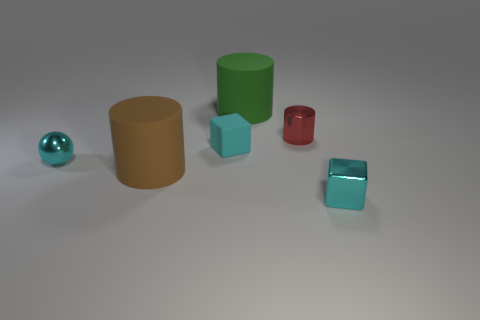Are there any objects that have a reflective surface? Yes, there are a couple of objects with reflective surfaces. The cyan sphere and the two cyan blocks have a shiny, reflective metallic finish. 